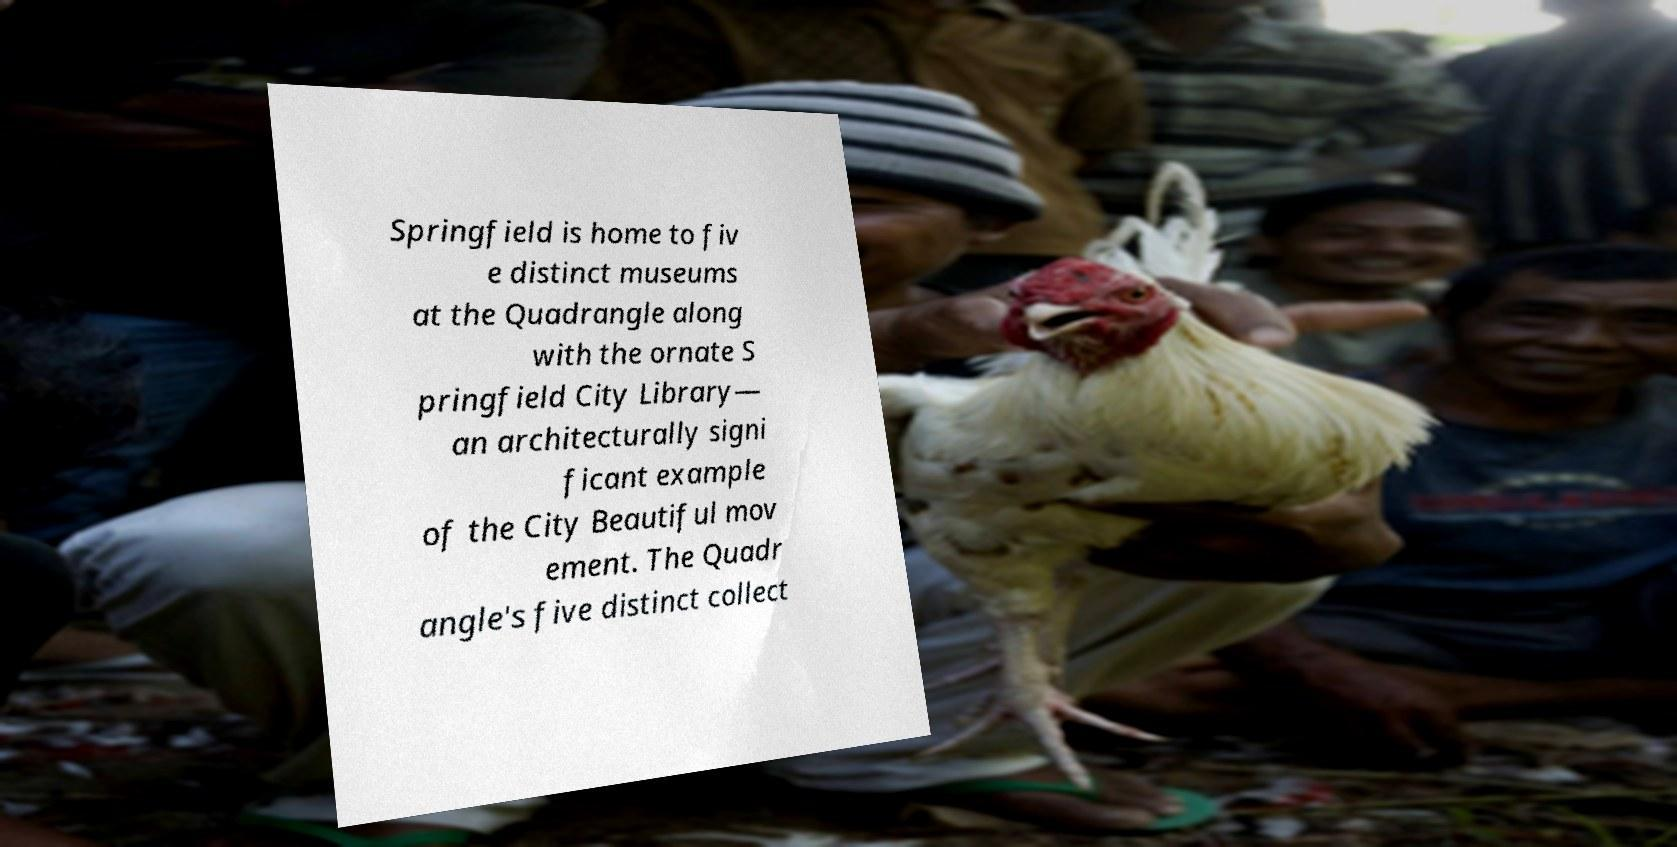Can you accurately transcribe the text from the provided image for me? Springfield is home to fiv e distinct museums at the Quadrangle along with the ornate S pringfield City Library— an architecturally signi ficant example of the City Beautiful mov ement. The Quadr angle's five distinct collect 